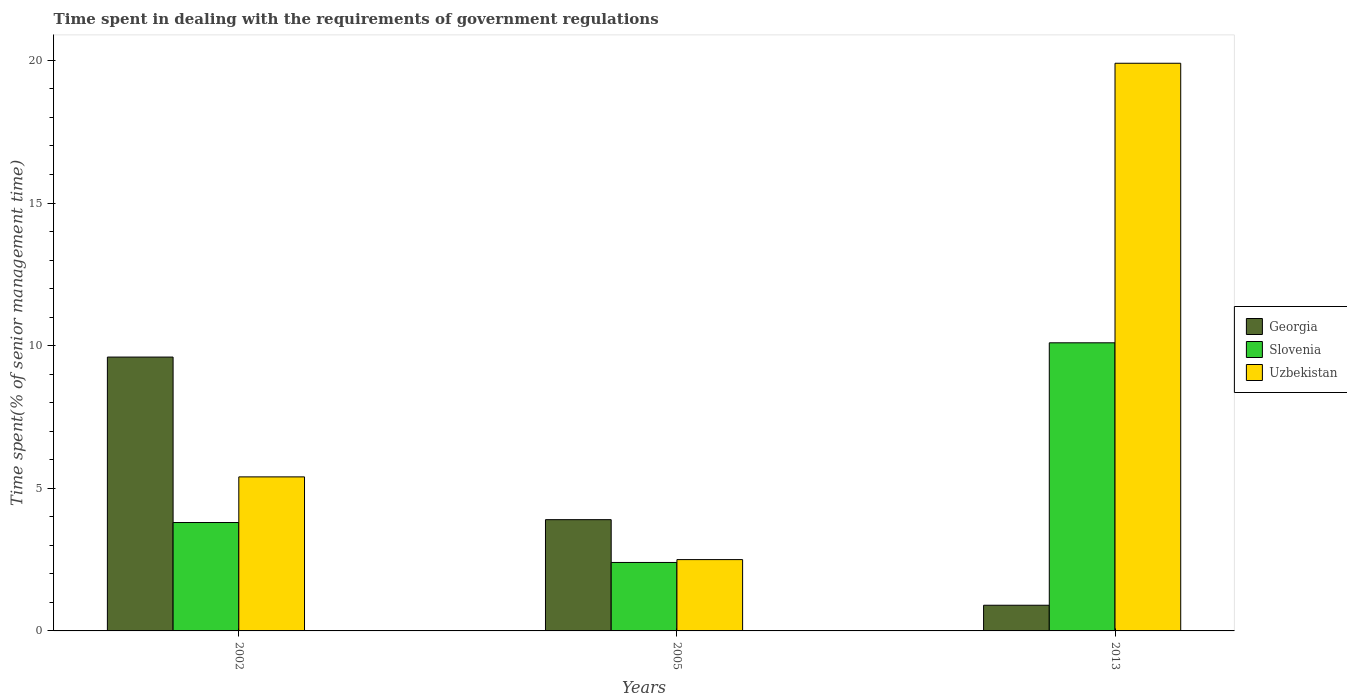How many groups of bars are there?
Make the answer very short. 3. Are the number of bars per tick equal to the number of legend labels?
Keep it short and to the point. Yes. How many bars are there on the 2nd tick from the right?
Provide a short and direct response. 3. What is the label of the 3rd group of bars from the left?
Offer a very short reply. 2013. In how many cases, is the number of bars for a given year not equal to the number of legend labels?
Your response must be concise. 0. What is the time spent while dealing with the requirements of government regulations in Slovenia in 2013?
Provide a succinct answer. 10.1. Across all years, what is the minimum time spent while dealing with the requirements of government regulations in Georgia?
Ensure brevity in your answer.  0.9. What is the total time spent while dealing with the requirements of government regulations in Slovenia in the graph?
Your answer should be compact. 16.3. What is the difference between the time spent while dealing with the requirements of government regulations in Slovenia in 2002 and the time spent while dealing with the requirements of government regulations in Georgia in 2013?
Offer a terse response. 2.9. What is the average time spent while dealing with the requirements of government regulations in Georgia per year?
Offer a terse response. 4.8. In the year 2002, what is the difference between the time spent while dealing with the requirements of government regulations in Georgia and time spent while dealing with the requirements of government regulations in Uzbekistan?
Provide a succinct answer. 4.2. In how many years, is the time spent while dealing with the requirements of government regulations in Slovenia greater than 18 %?
Ensure brevity in your answer.  0. What is the ratio of the time spent while dealing with the requirements of government regulations in Georgia in 2002 to that in 2013?
Keep it short and to the point. 10.67. What is the difference between the highest and the second highest time spent while dealing with the requirements of government regulations in Georgia?
Your answer should be very brief. 5.7. What is the difference between the highest and the lowest time spent while dealing with the requirements of government regulations in Slovenia?
Make the answer very short. 7.7. What does the 3rd bar from the left in 2013 represents?
Your answer should be very brief. Uzbekistan. What does the 2nd bar from the right in 2013 represents?
Provide a succinct answer. Slovenia. Is it the case that in every year, the sum of the time spent while dealing with the requirements of government regulations in Slovenia and time spent while dealing with the requirements of government regulations in Georgia is greater than the time spent while dealing with the requirements of government regulations in Uzbekistan?
Your answer should be compact. No. How many bars are there?
Provide a short and direct response. 9. Are all the bars in the graph horizontal?
Offer a terse response. No. Are the values on the major ticks of Y-axis written in scientific E-notation?
Offer a terse response. No. Does the graph contain grids?
Give a very brief answer. No. How are the legend labels stacked?
Provide a short and direct response. Vertical. What is the title of the graph?
Offer a very short reply. Time spent in dealing with the requirements of government regulations. What is the label or title of the X-axis?
Your answer should be compact. Years. What is the label or title of the Y-axis?
Provide a short and direct response. Time spent(% of senior management time). What is the Time spent(% of senior management time) in Georgia in 2002?
Your answer should be compact. 9.6. What is the Time spent(% of senior management time) of Slovenia in 2002?
Your answer should be compact. 3.8. What is the Time spent(% of senior management time) in Georgia in 2005?
Provide a short and direct response. 3.9. What is the Time spent(% of senior management time) in Slovenia in 2005?
Offer a very short reply. 2.4. What is the Time spent(% of senior management time) of Uzbekistan in 2005?
Offer a terse response. 2.5. What is the Time spent(% of senior management time) of Uzbekistan in 2013?
Keep it short and to the point. 19.9. Across all years, what is the maximum Time spent(% of senior management time) in Georgia?
Your response must be concise. 9.6. Across all years, what is the maximum Time spent(% of senior management time) of Slovenia?
Offer a terse response. 10.1. Across all years, what is the minimum Time spent(% of senior management time) in Georgia?
Provide a succinct answer. 0.9. Across all years, what is the minimum Time spent(% of senior management time) of Slovenia?
Give a very brief answer. 2.4. Across all years, what is the minimum Time spent(% of senior management time) of Uzbekistan?
Your answer should be very brief. 2.5. What is the total Time spent(% of senior management time) of Uzbekistan in the graph?
Your response must be concise. 27.8. What is the difference between the Time spent(% of senior management time) of Uzbekistan in 2002 and that in 2005?
Give a very brief answer. 2.9. What is the difference between the Time spent(% of senior management time) in Uzbekistan in 2002 and that in 2013?
Make the answer very short. -14.5. What is the difference between the Time spent(% of senior management time) in Georgia in 2005 and that in 2013?
Provide a short and direct response. 3. What is the difference between the Time spent(% of senior management time) of Slovenia in 2005 and that in 2013?
Offer a very short reply. -7.7. What is the difference between the Time spent(% of senior management time) of Uzbekistan in 2005 and that in 2013?
Provide a short and direct response. -17.4. What is the difference between the Time spent(% of senior management time) in Georgia in 2002 and the Time spent(% of senior management time) in Uzbekistan in 2013?
Give a very brief answer. -10.3. What is the difference between the Time spent(% of senior management time) in Slovenia in 2002 and the Time spent(% of senior management time) in Uzbekistan in 2013?
Make the answer very short. -16.1. What is the difference between the Time spent(% of senior management time) in Georgia in 2005 and the Time spent(% of senior management time) in Slovenia in 2013?
Make the answer very short. -6.2. What is the difference between the Time spent(% of senior management time) of Slovenia in 2005 and the Time spent(% of senior management time) of Uzbekistan in 2013?
Provide a short and direct response. -17.5. What is the average Time spent(% of senior management time) of Georgia per year?
Offer a very short reply. 4.8. What is the average Time spent(% of senior management time) of Slovenia per year?
Your answer should be compact. 5.43. What is the average Time spent(% of senior management time) in Uzbekistan per year?
Keep it short and to the point. 9.27. In the year 2005, what is the difference between the Time spent(% of senior management time) in Georgia and Time spent(% of senior management time) in Slovenia?
Offer a very short reply. 1.5. In the year 2013, what is the difference between the Time spent(% of senior management time) of Georgia and Time spent(% of senior management time) of Uzbekistan?
Keep it short and to the point. -19. In the year 2013, what is the difference between the Time spent(% of senior management time) of Slovenia and Time spent(% of senior management time) of Uzbekistan?
Make the answer very short. -9.8. What is the ratio of the Time spent(% of senior management time) of Georgia in 2002 to that in 2005?
Your answer should be compact. 2.46. What is the ratio of the Time spent(% of senior management time) in Slovenia in 2002 to that in 2005?
Your response must be concise. 1.58. What is the ratio of the Time spent(% of senior management time) of Uzbekistan in 2002 to that in 2005?
Your answer should be compact. 2.16. What is the ratio of the Time spent(% of senior management time) of Georgia in 2002 to that in 2013?
Ensure brevity in your answer.  10.67. What is the ratio of the Time spent(% of senior management time) of Slovenia in 2002 to that in 2013?
Offer a terse response. 0.38. What is the ratio of the Time spent(% of senior management time) of Uzbekistan in 2002 to that in 2013?
Make the answer very short. 0.27. What is the ratio of the Time spent(% of senior management time) of Georgia in 2005 to that in 2013?
Ensure brevity in your answer.  4.33. What is the ratio of the Time spent(% of senior management time) of Slovenia in 2005 to that in 2013?
Your answer should be very brief. 0.24. What is the ratio of the Time spent(% of senior management time) in Uzbekistan in 2005 to that in 2013?
Offer a terse response. 0.13. What is the difference between the highest and the second highest Time spent(% of senior management time) in Georgia?
Make the answer very short. 5.7. What is the difference between the highest and the second highest Time spent(% of senior management time) in Slovenia?
Your answer should be very brief. 6.3. What is the difference between the highest and the second highest Time spent(% of senior management time) of Uzbekistan?
Provide a succinct answer. 14.5. What is the difference between the highest and the lowest Time spent(% of senior management time) in Georgia?
Offer a very short reply. 8.7. What is the difference between the highest and the lowest Time spent(% of senior management time) in Slovenia?
Make the answer very short. 7.7. 